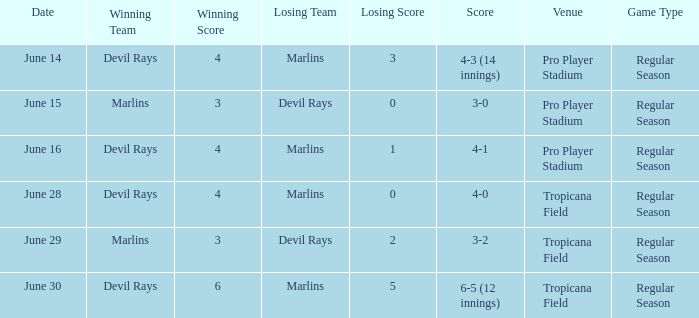What was the score on june 16? 4-1. 